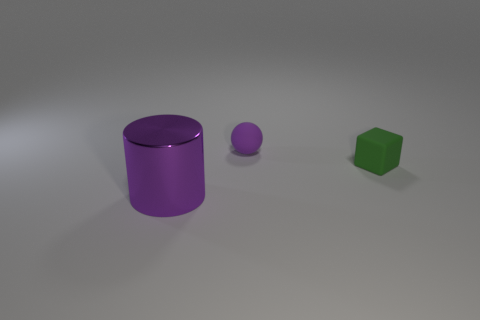Add 2 tiny green rubber cubes. How many objects exist? 5 Subtract all blocks. How many objects are left? 2 Subtract all blocks. Subtract all purple metallic cylinders. How many objects are left? 1 Add 2 small green matte cubes. How many small green matte cubes are left? 3 Add 3 tiny red balls. How many tiny red balls exist? 3 Subtract 0 cyan balls. How many objects are left? 3 